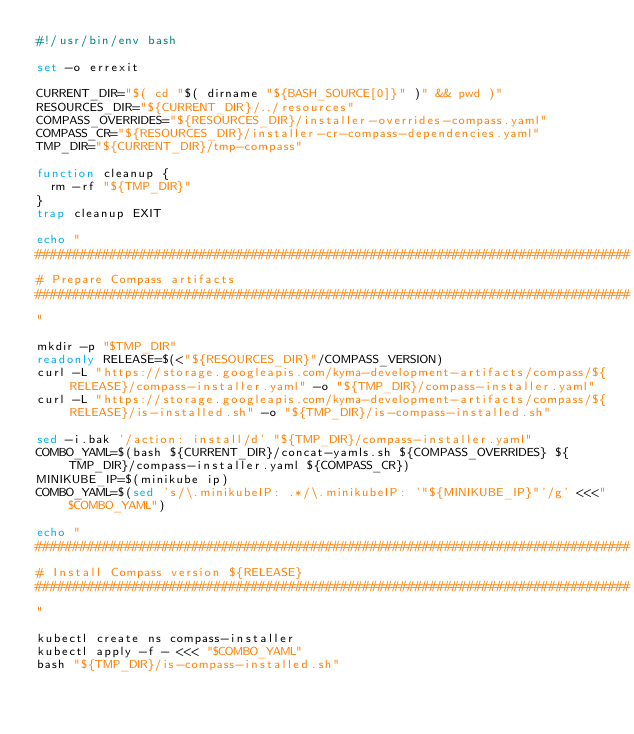<code> <loc_0><loc_0><loc_500><loc_500><_Bash_>#!/usr/bin/env bash

set -o errexit

CURRENT_DIR="$( cd "$( dirname "${BASH_SOURCE[0]}" )" && pwd )"
RESOURCES_DIR="${CURRENT_DIR}/../resources"
COMPASS_OVERRIDES="${RESOURCES_DIR}/installer-overrides-compass.yaml"
COMPASS_CR="${RESOURCES_DIR}/installer-cr-compass-dependencies.yaml"
TMP_DIR="${CURRENT_DIR}/tmp-compass"

function cleanup {
  rm -rf "${TMP_DIR}"
}
trap cleanup EXIT

echo "
################################################################################
# Prepare Compass artifacts
################################################################################
"

mkdir -p "$TMP_DIR"
readonly RELEASE=$(<"${RESOURCES_DIR}"/COMPASS_VERSION)
curl -L "https://storage.googleapis.com/kyma-development-artifacts/compass/${RELEASE}/compass-installer.yaml" -o "${TMP_DIR}/compass-installer.yaml"
curl -L "https://storage.googleapis.com/kyma-development-artifacts/compass/${RELEASE}/is-installed.sh" -o "${TMP_DIR}/is-compass-installed.sh"

sed -i.bak '/action: install/d' "${TMP_DIR}/compass-installer.yaml"
COMBO_YAML=$(bash ${CURRENT_DIR}/concat-yamls.sh ${COMPASS_OVERRIDES} ${TMP_DIR}/compass-installer.yaml ${COMPASS_CR})
MINIKUBE_IP=$(minikube ip)
COMBO_YAML=$(sed 's/\.minikubeIP: .*/\.minikubeIP: '"${MINIKUBE_IP}"'/g' <<<"$COMBO_YAML")

echo "
################################################################################
# Install Compass version ${RELEASE}
################################################################################
"

kubectl create ns compass-installer
kubectl apply -f - <<< "$COMBO_YAML"
bash "${TMP_DIR}/is-compass-installed.sh"
</code> 